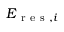Convert formula to latex. <formula><loc_0><loc_0><loc_500><loc_500>E _ { r e s , i }</formula> 